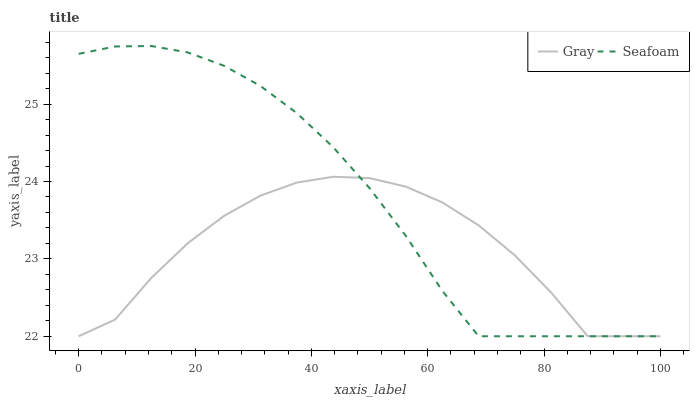Does Gray have the minimum area under the curve?
Answer yes or no. Yes. Does Seafoam have the maximum area under the curve?
Answer yes or no. Yes. Does Seafoam have the minimum area under the curve?
Answer yes or no. No. Is Seafoam the smoothest?
Answer yes or no. Yes. Is Gray the roughest?
Answer yes or no. Yes. Is Seafoam the roughest?
Answer yes or no. No. 